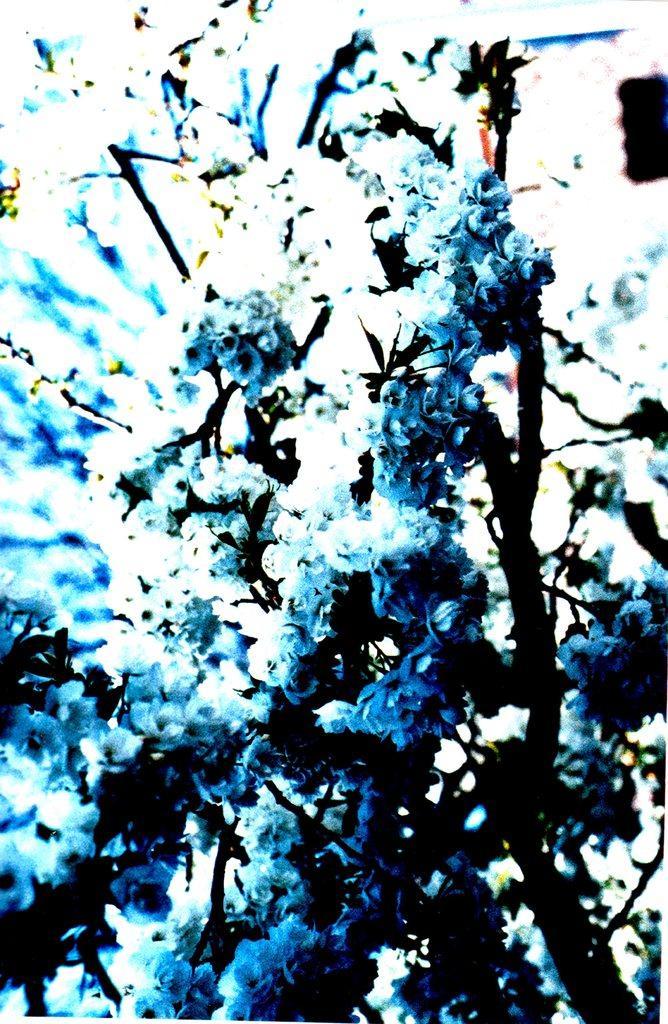How would you summarize this image in a sentence or two? In this picture I can see a plant. 